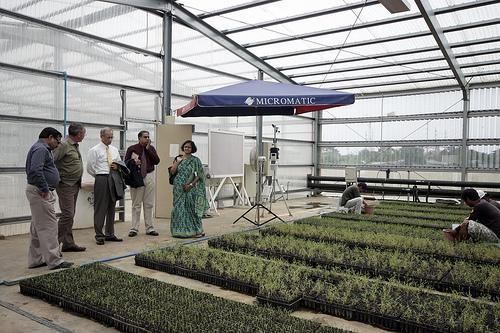In the image, identify the occupation of one of the people. A worker in the greenhouse is squatting down, possibly tending to the plants or using a ceramic pot.  Briefly describe the attire of the woman in the image. The woman is wearing a green designed dress, standing among the men and objects in the greenhouse. Describe the attire of the individuals present in the image. There are men wearing shirts with different colors and ties, one in dress clothes, a woman in a colorful dress, and a man squatting in a green shirt and shorts. Provide a brief overview of the scene in the image. The image shows a group of people and various objects in a greenhouse setting with rows of green plants and a large sun umbrella. Describe the location and setting where the image is taken. The image is set in a greenhouse, featuring rows of green plants, large windows, and a group of people mingling around. List some objects found in the image. A blue and red umbrella, rows of green plants, a large white board, a black tripod, and a metallic grey umbrella stand. Mention the main elements in the image with their respective colors. The image has men wearing white, blue, black, and maroon shirts, a woman in a green dress, a blue and red umbrella with white lettering, and rows of green plants. Mention a unique feature of the umbrella displayed in the image. The blue and red umbrella has white micromatic text written on it, making it noticeably unique. State the primary activity occurring amongst the individuals in the image. There are people interacting and engaging with objects and plants within a greenhouse setting. Highlight the most eye-catching element in the image. A blue and red sun umbrella with white lettering stands out prominently in the scene. 